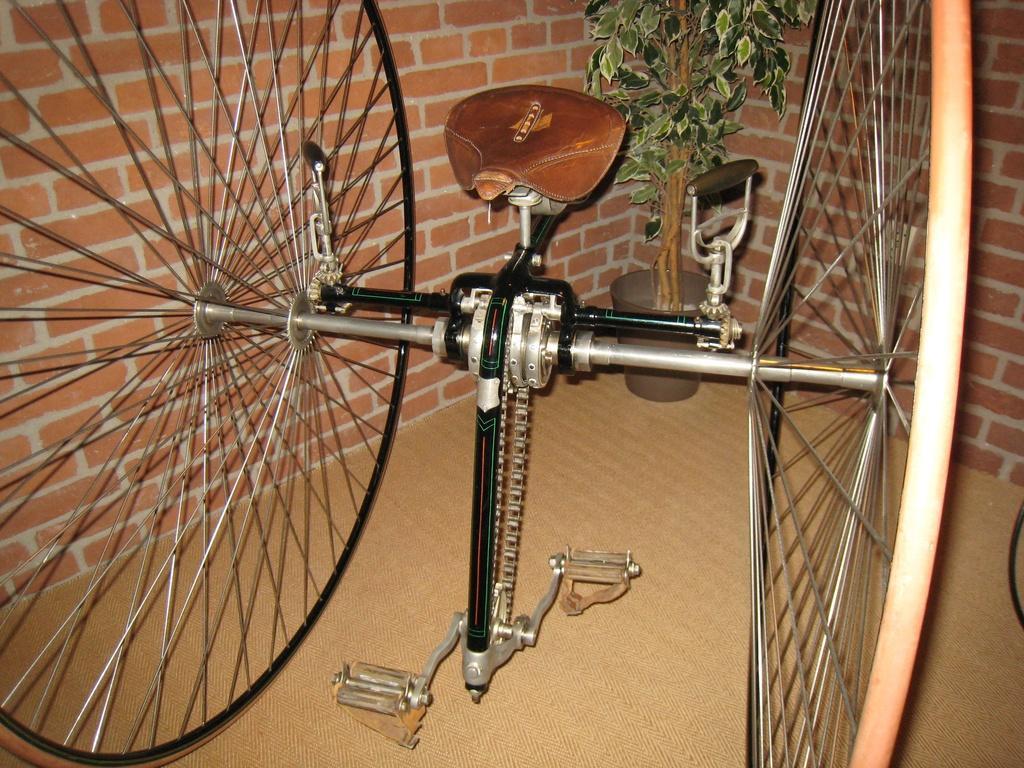Please provide a concise description of this image. In this image we can see a vehicle placed on the ground. In the background we can see a plant in pot and the wall. 